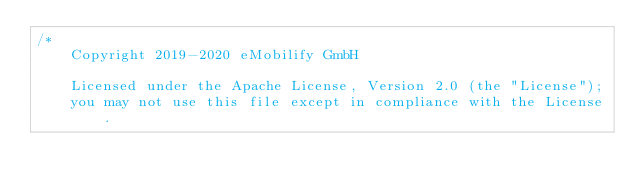Convert code to text. <code><loc_0><loc_0><loc_500><loc_500><_Kotlin_>/*
    Copyright 2019-2020 eMobilify GmbH

    Licensed under the Apache License, Version 2.0 (the "License");
    you may not use this file except in compliance with the License.</code> 